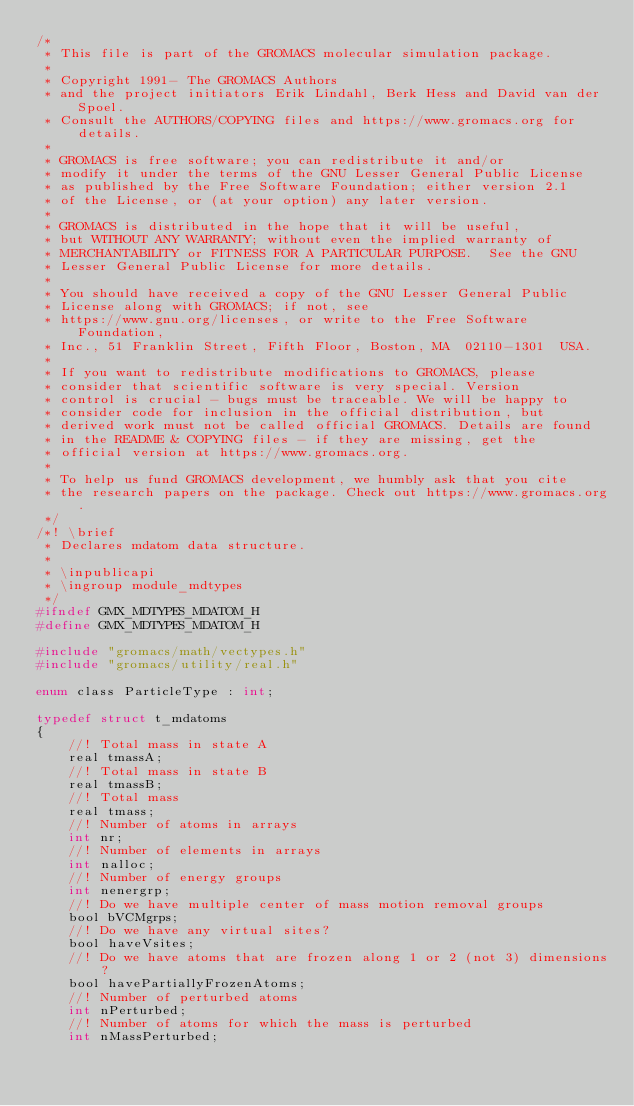Convert code to text. <code><loc_0><loc_0><loc_500><loc_500><_C_>/*
 * This file is part of the GROMACS molecular simulation package.
 *
 * Copyright 1991- The GROMACS Authors
 * and the project initiators Erik Lindahl, Berk Hess and David van der Spoel.
 * Consult the AUTHORS/COPYING files and https://www.gromacs.org for details.
 *
 * GROMACS is free software; you can redistribute it and/or
 * modify it under the terms of the GNU Lesser General Public License
 * as published by the Free Software Foundation; either version 2.1
 * of the License, or (at your option) any later version.
 *
 * GROMACS is distributed in the hope that it will be useful,
 * but WITHOUT ANY WARRANTY; without even the implied warranty of
 * MERCHANTABILITY or FITNESS FOR A PARTICULAR PURPOSE.  See the GNU
 * Lesser General Public License for more details.
 *
 * You should have received a copy of the GNU Lesser General Public
 * License along with GROMACS; if not, see
 * https://www.gnu.org/licenses, or write to the Free Software Foundation,
 * Inc., 51 Franklin Street, Fifth Floor, Boston, MA  02110-1301  USA.
 *
 * If you want to redistribute modifications to GROMACS, please
 * consider that scientific software is very special. Version
 * control is crucial - bugs must be traceable. We will be happy to
 * consider code for inclusion in the official distribution, but
 * derived work must not be called official GROMACS. Details are found
 * in the README & COPYING files - if they are missing, get the
 * official version at https://www.gromacs.org.
 *
 * To help us fund GROMACS development, we humbly ask that you cite
 * the research papers on the package. Check out https://www.gromacs.org.
 */
/*! \brief
 * Declares mdatom data structure.
 *
 * \inpublicapi
 * \ingroup module_mdtypes
 */
#ifndef GMX_MDTYPES_MDATOM_H
#define GMX_MDTYPES_MDATOM_H

#include "gromacs/math/vectypes.h"
#include "gromacs/utility/real.h"

enum class ParticleType : int;

typedef struct t_mdatoms
{
    //! Total mass in state A
    real tmassA;
    //! Total mass in state B
    real tmassB;
    //! Total mass
    real tmass;
    //! Number of atoms in arrays
    int nr;
    //! Number of elements in arrays
    int nalloc;
    //! Number of energy groups
    int nenergrp;
    //! Do we have multiple center of mass motion removal groups
    bool bVCMgrps;
    //! Do we have any virtual sites?
    bool haveVsites;
    //! Do we have atoms that are frozen along 1 or 2 (not 3) dimensions?
    bool havePartiallyFrozenAtoms;
    //! Number of perturbed atoms
    int nPerturbed;
    //! Number of atoms for which the mass is perturbed
    int nMassPerturbed;</code> 